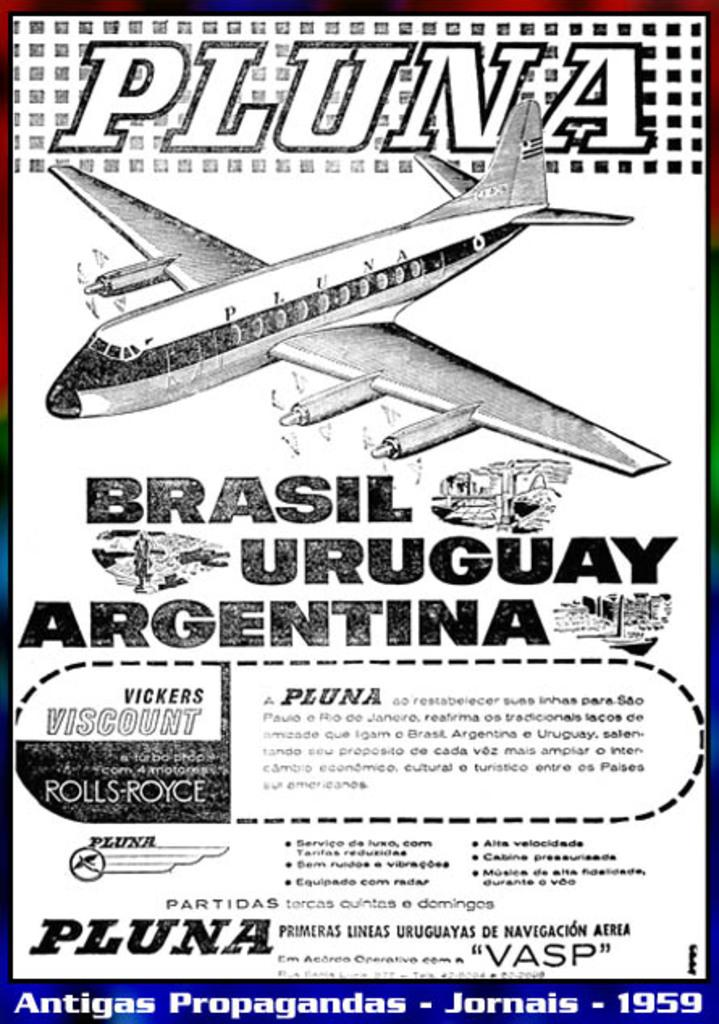<image>
Create a compact narrative representing the image presented. Flyer for flights to Brazil, Uruguay and Argentina. 